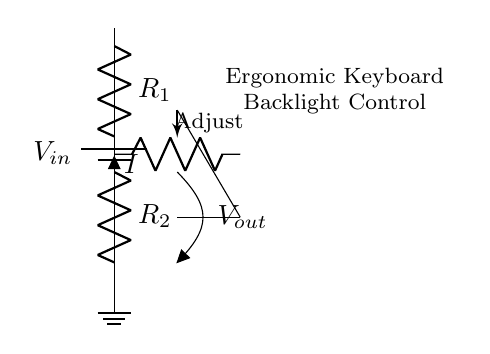What is the function of the potentiometer in this circuit? The potentiometer allows for variable resistance, which adjusts the output voltage and thereby controls the intensity of the backlight.
Answer: variable resistor What are the values of the resistors? The resistor values are labeled in the circuit as R1 and R2, but the exact numerical values are not provided in the diagram.
Answer: R1 and R2 What indicates that this circuit is a voltage divider? A voltage divider circuit is characterized by having two resistors in series, where the output voltage is taken from the junction between them. This is shown in the diagram where R1 and R2 are in series and connected to the output.
Answer: two series resistors What is the output voltage based on R1 and R2 values? The output voltage is determined by the voltage division rule, Vout = Vin * (R2 / (R1 + R2)). The specific values for R1 and R2 are necessary to compute a numeric answer, which is not given.
Answer: depends on R1 and R2 What component is used to represent backlighting in this circuit? The LED component marked in yellow is used to represent the backlight function in this ergonomic keyboard circuit.
Answer: LED How does adjusting the potentiometer affect the output voltage? Adjusting the potentiometer changes its resistance, influencing the voltage ratio across R2, which directly modifies the output voltage, thus affecting the backlight brightness.
Answer: changes output voltage 